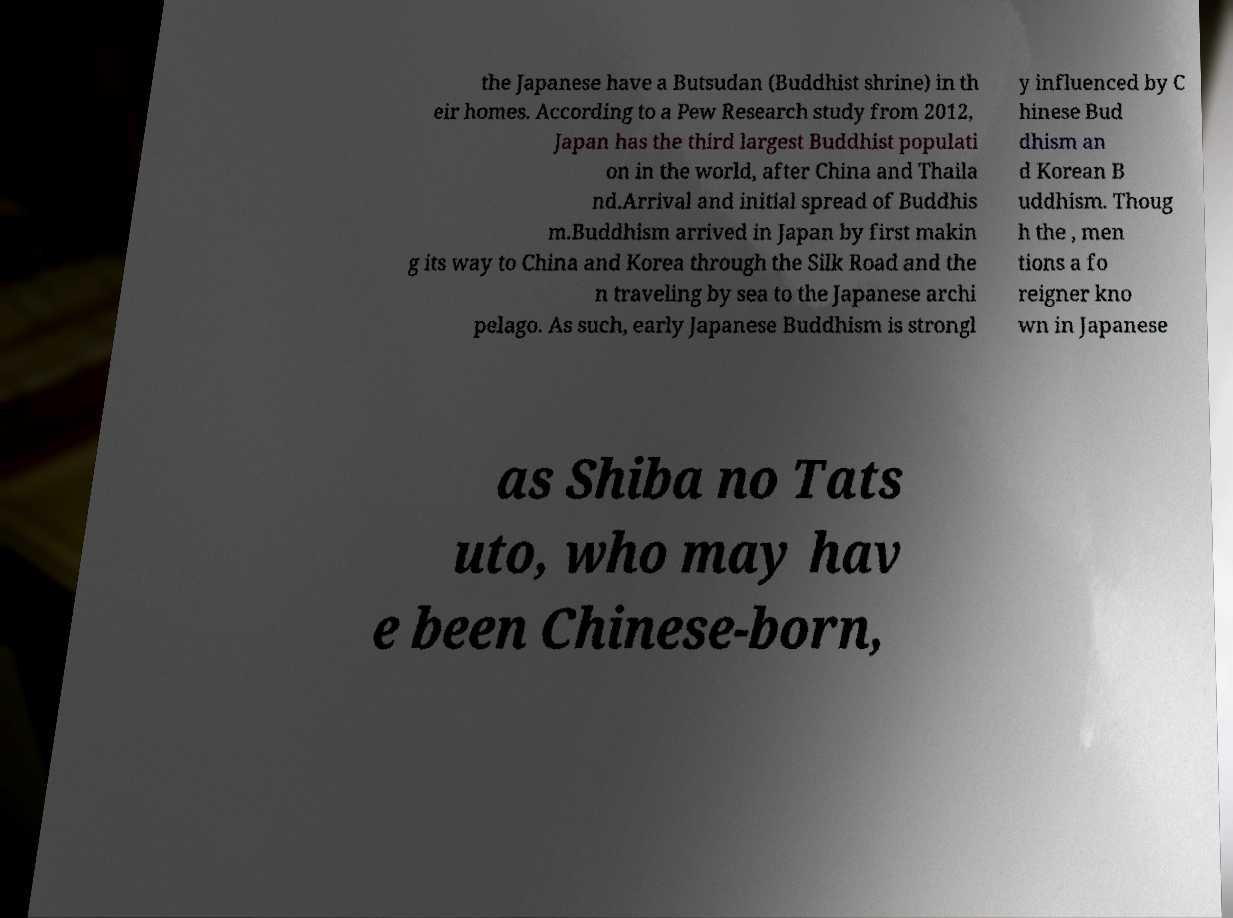There's text embedded in this image that I need extracted. Can you transcribe it verbatim? the Japanese have a Butsudan (Buddhist shrine) in th eir homes. According to a Pew Research study from 2012, Japan has the third largest Buddhist populati on in the world, after China and Thaila nd.Arrival and initial spread of Buddhis m.Buddhism arrived in Japan by first makin g its way to China and Korea through the Silk Road and the n traveling by sea to the Japanese archi pelago. As such, early Japanese Buddhism is strongl y influenced by C hinese Bud dhism an d Korean B uddhism. Thoug h the , men tions a fo reigner kno wn in Japanese as Shiba no Tats uto, who may hav e been Chinese-born, 